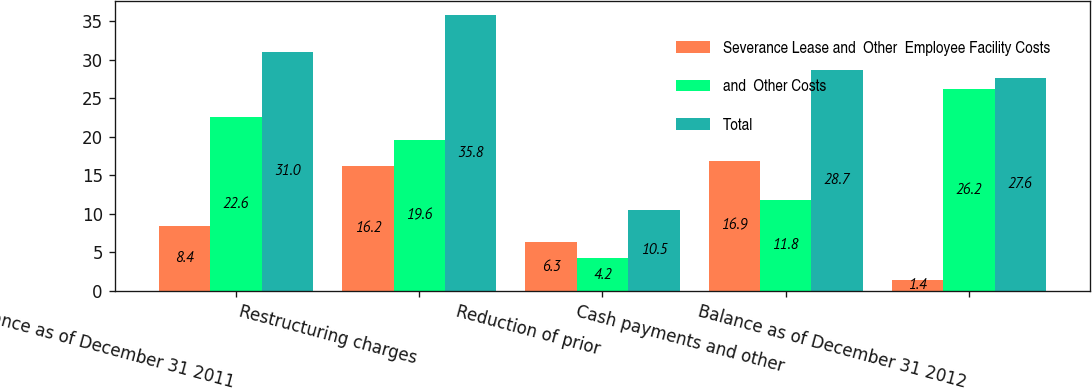Convert chart. <chart><loc_0><loc_0><loc_500><loc_500><stacked_bar_chart><ecel><fcel>Balance as of December 31 2011<fcel>Restructuring charges<fcel>Reduction of prior<fcel>Cash payments and other<fcel>Balance as of December 31 2012<nl><fcel>Severance Lease and  Other  Employee Facility Costs<fcel>8.4<fcel>16.2<fcel>6.3<fcel>16.9<fcel>1.4<nl><fcel>and  Other Costs<fcel>22.6<fcel>19.6<fcel>4.2<fcel>11.8<fcel>26.2<nl><fcel>Total<fcel>31<fcel>35.8<fcel>10.5<fcel>28.7<fcel>27.6<nl></chart> 